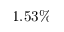Convert formula to latex. <formula><loc_0><loc_0><loc_500><loc_500>1 . 5 3 \%</formula> 